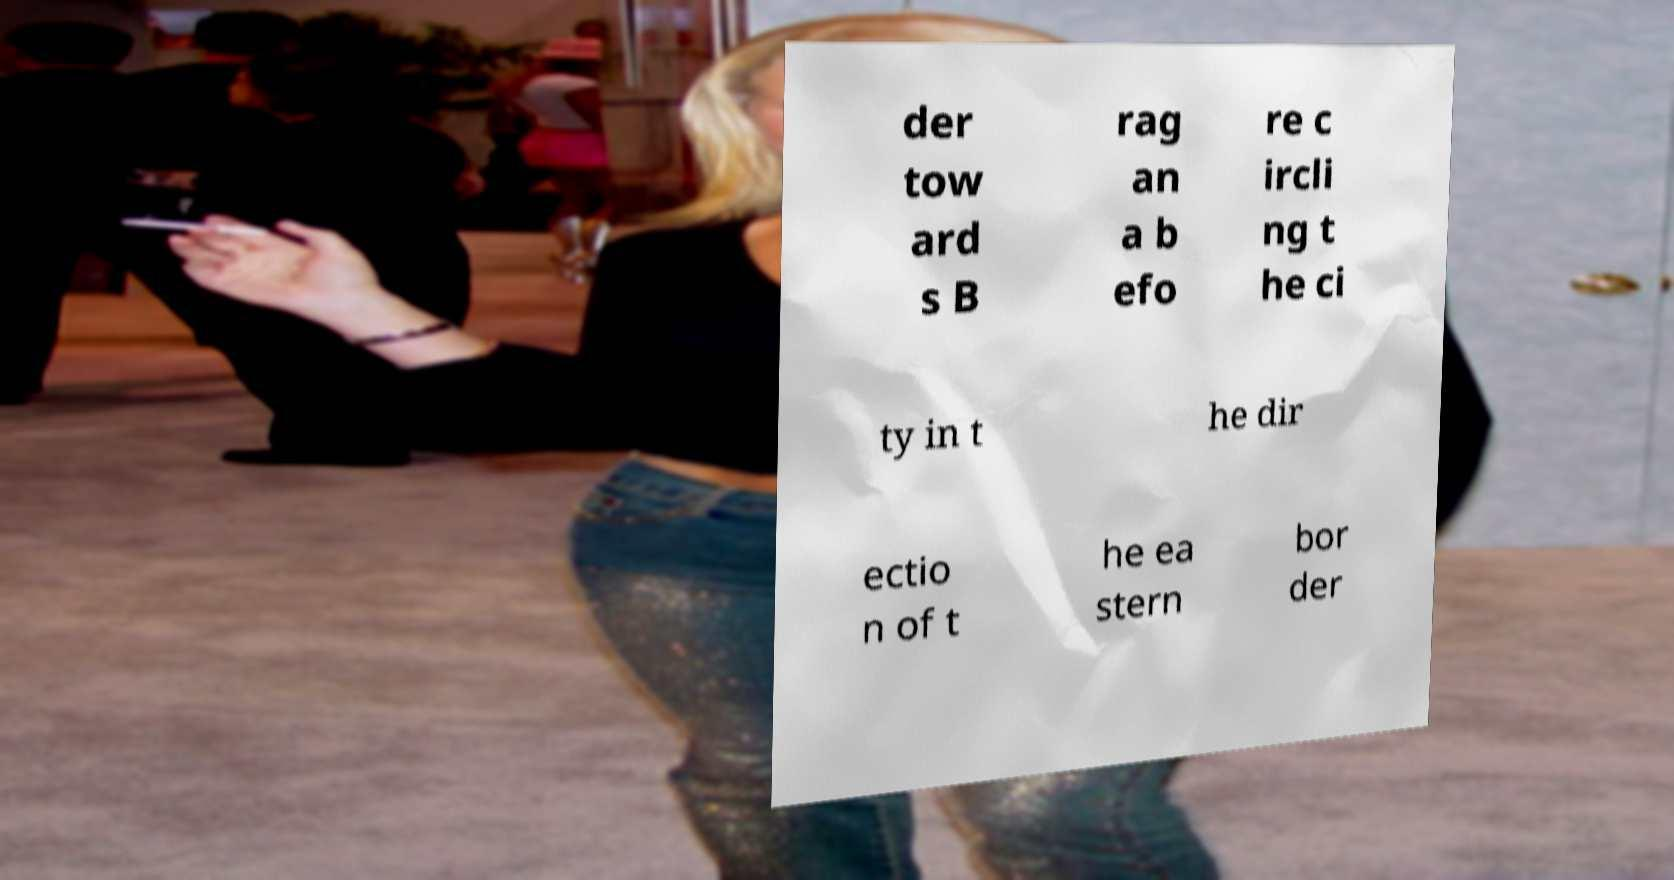There's text embedded in this image that I need extracted. Can you transcribe it verbatim? der tow ard s B rag an a b efo re c ircli ng t he ci ty in t he dir ectio n of t he ea stern bor der 